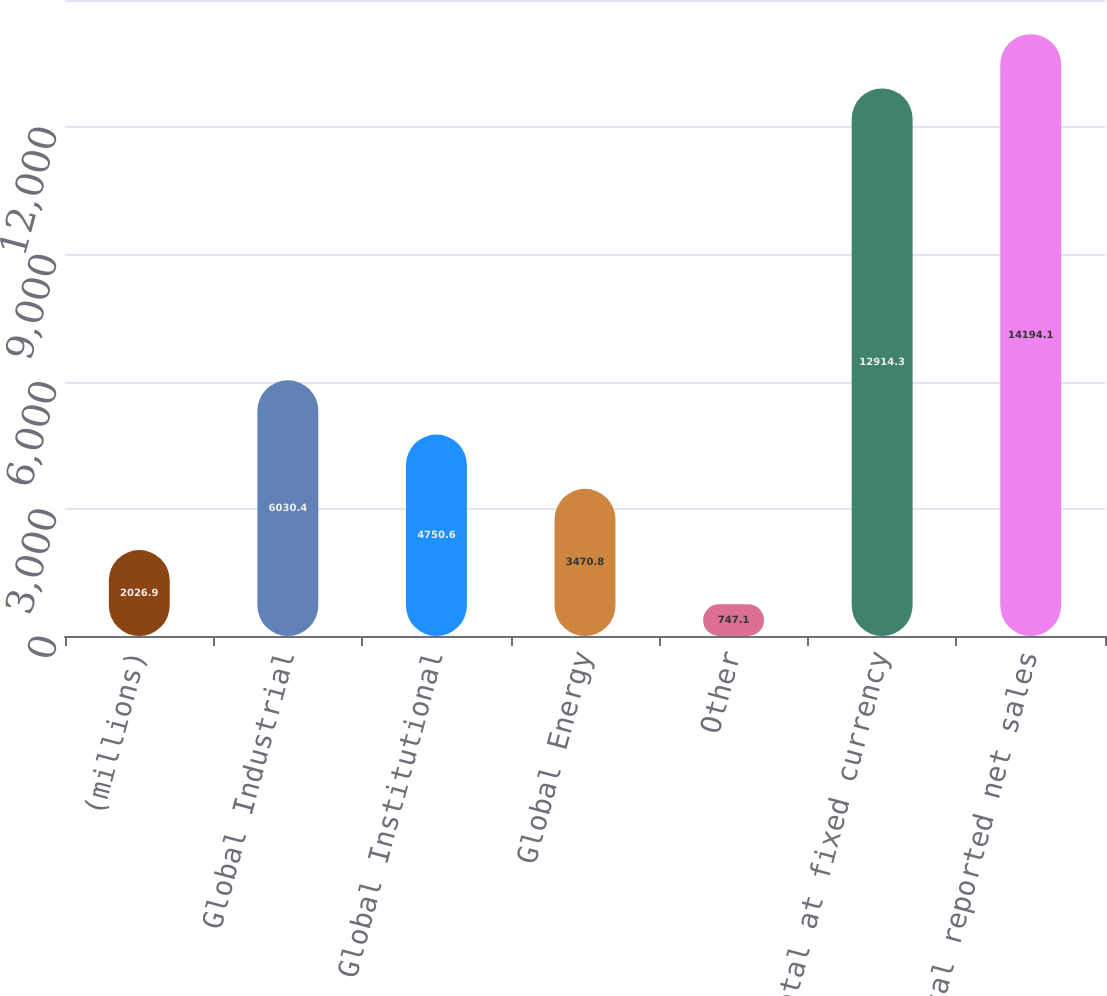Convert chart. <chart><loc_0><loc_0><loc_500><loc_500><bar_chart><fcel>(millions)<fcel>Global Industrial<fcel>Global Institutional<fcel>Global Energy<fcel>Other<fcel>Subtotal at fixed currency<fcel>Total reported net sales<nl><fcel>2026.9<fcel>6030.4<fcel>4750.6<fcel>3470.8<fcel>747.1<fcel>12914.3<fcel>14194.1<nl></chart> 